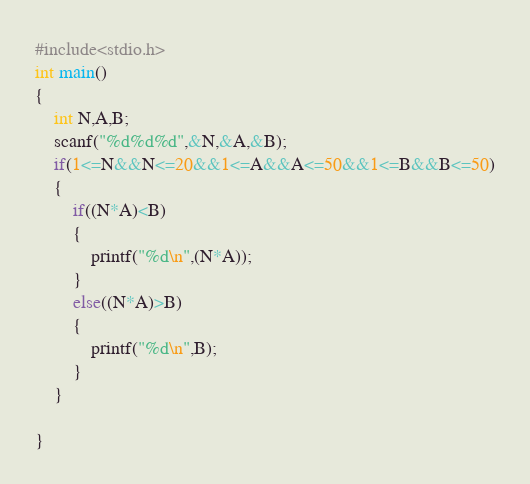<code> <loc_0><loc_0><loc_500><loc_500><_C_>#include<stdio.h>
int main()
{
    int N,A,B;
    scanf("%d%d%d",&N,&A,&B);
    if(1<=N&&N<=20&&1<=A&&A<=50&&1<=B&&B<=50)
    {
        if((N*A)<B)
        {
            printf("%d\n",(N*A));
        }
        else((N*A)>B)
        {
            printf("%d\n",B);
        }
    }

}
</code> 